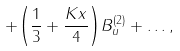Convert formula to latex. <formula><loc_0><loc_0><loc_500><loc_500>+ { \left ( { \frac { 1 } { 3 } } + { \frac { K x } { 4 } } \right ) } B _ { u } ^ { ( 2 ) } + \dots ,</formula> 